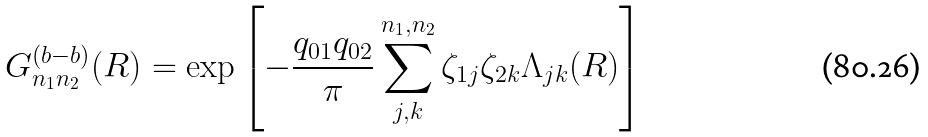Convert formula to latex. <formula><loc_0><loc_0><loc_500><loc_500>G ^ { ( b - b ) } _ { n _ { 1 } n _ { 2 } } ( { R } ) = \exp \left [ - \frac { q _ { 0 1 } q _ { 0 2 } } { \pi } \sum _ { j , k } ^ { n _ { 1 } , n _ { 2 } } \zeta _ { 1 j } \zeta _ { 2 k } \Lambda _ { j k } ( { R } ) \right ]</formula> 